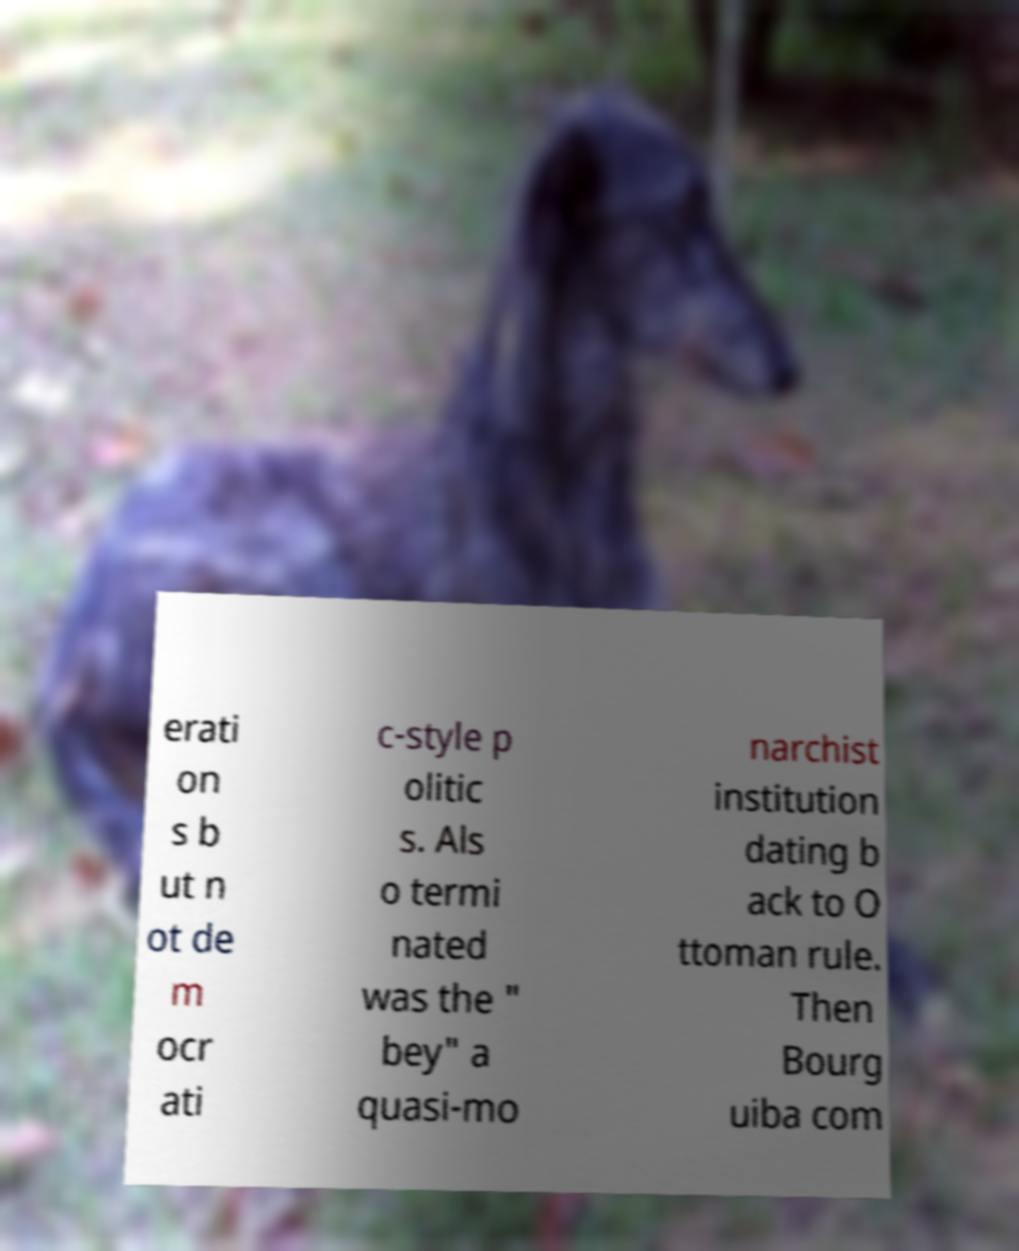Can you accurately transcribe the text from the provided image for me? erati on s b ut n ot de m ocr ati c-style p olitic s. Als o termi nated was the " bey" a quasi-mo narchist institution dating b ack to O ttoman rule. Then Bourg uiba com 